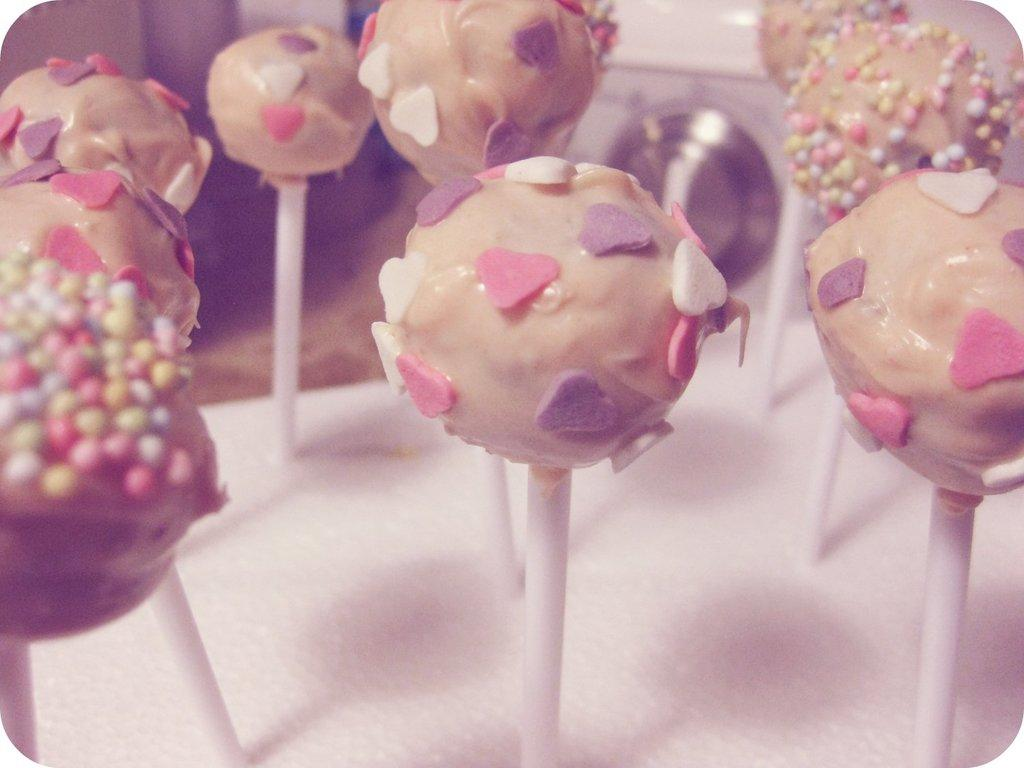What is the main subject in the center of the image? There are candies in the center of the image. What can be seen in the background of the image? There is a washing machine and a wall in the background of the image. What type of branch can be seen growing from the candies in the image? There is no branch present in the image; it features candies in the center and a washing machine and a wall in the background. 